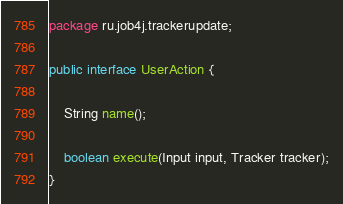Convert code to text. <code><loc_0><loc_0><loc_500><loc_500><_Java_>package ru.job4j.trackerupdate;

public interface UserAction {

    String name();

    boolean execute(Input input, Tracker tracker);
}
</code> 